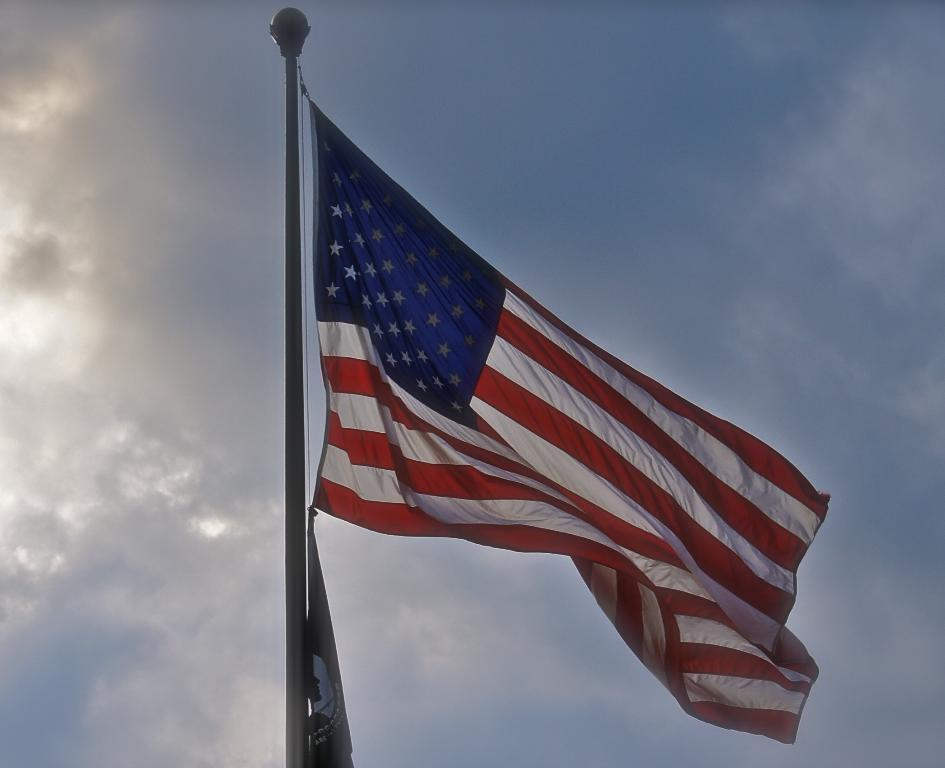What is the main object in the image? There is a flag in the image. How is the flag attached to the pole? The flag is attached to a thread, and the thread is connected to a pole. What can be seen in the background of the image? There are clouds in the background of the image. What color is the sky in the image? The sky is blue in the image. Where is the baby's birth certificate located in the image? There is no baby or birth certificate present in the image; it only features a flag, thread, pole, clouds, and a blue sky. 